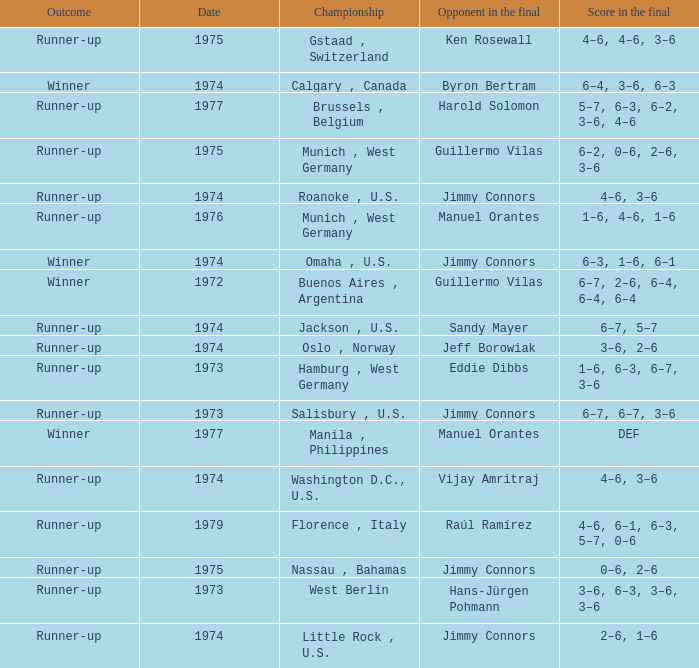What was the final score with Guillermo Vilas as the opponent in the final, that happened after 1972? 6–2, 0–6, 2–6, 3–6. 